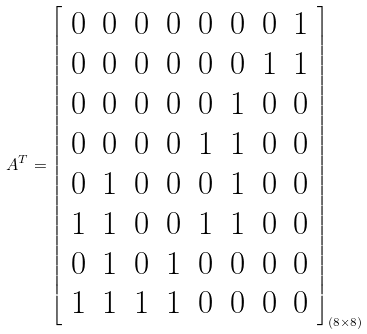<formula> <loc_0><loc_0><loc_500><loc_500>A ^ { T } = \left [ \begin{array} { c c c c c c c c } 0 & 0 & 0 & 0 & 0 & 0 & 0 & 1 \\ 0 & 0 & 0 & 0 & 0 & 0 & 1 & 1 \\ 0 & 0 & 0 & 0 & 0 & 1 & 0 & 0 \\ 0 & 0 & 0 & 0 & 1 & 1 & 0 & 0 \\ 0 & 1 & 0 & 0 & 0 & 1 & 0 & 0 \\ 1 & 1 & 0 & 0 & 1 & 1 & 0 & 0 \\ 0 & 1 & 0 & 1 & 0 & 0 & 0 & 0 \\ 1 & 1 & 1 & 1 & 0 & 0 & 0 & 0 \end{array} \right ] _ { \left ( 8 \times 8 \right ) }</formula> 